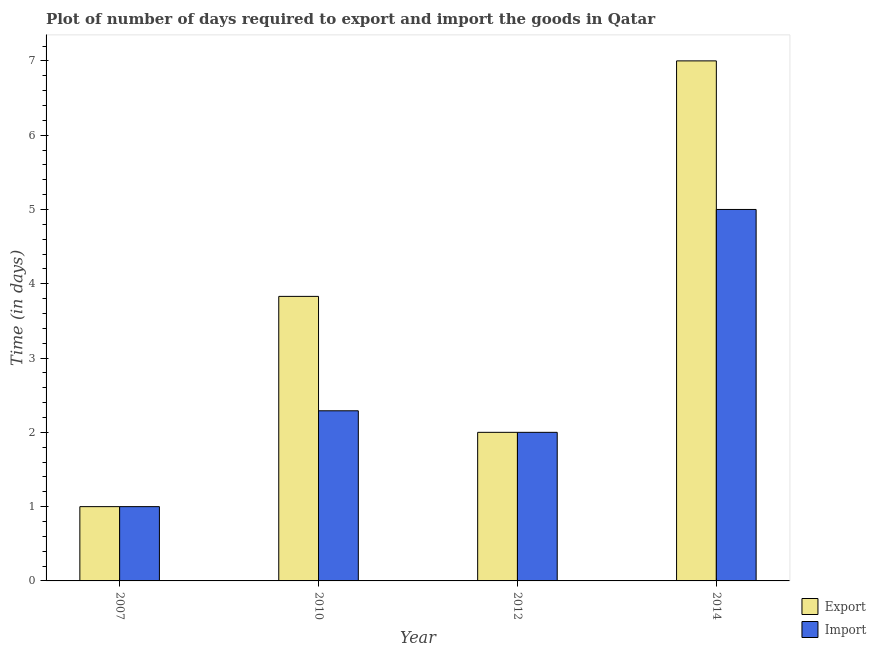How many different coloured bars are there?
Make the answer very short. 2. Are the number of bars on each tick of the X-axis equal?
Offer a very short reply. Yes. How many bars are there on the 3rd tick from the left?
Provide a succinct answer. 2. What is the time required to import in 2007?
Your answer should be compact. 1. Across all years, what is the maximum time required to import?
Your answer should be compact. 5. In which year was the time required to import maximum?
Your answer should be compact. 2014. In which year was the time required to import minimum?
Ensure brevity in your answer.  2007. What is the total time required to import in the graph?
Provide a short and direct response. 10.29. What is the difference between the time required to import in 2012 and that in 2014?
Offer a very short reply. -3. What is the difference between the time required to export in 2012 and the time required to import in 2010?
Offer a very short reply. -1.83. What is the average time required to import per year?
Provide a succinct answer. 2.57. In the year 2012, what is the difference between the time required to import and time required to export?
Your response must be concise. 0. What is the ratio of the time required to export in 2010 to that in 2014?
Your answer should be compact. 0.55. Is the time required to export in 2007 less than that in 2012?
Keep it short and to the point. Yes. What is the difference between the highest and the second highest time required to import?
Your answer should be very brief. 2.71. In how many years, is the time required to import greater than the average time required to import taken over all years?
Keep it short and to the point. 1. Is the sum of the time required to import in 2012 and 2014 greater than the maximum time required to export across all years?
Offer a very short reply. Yes. What does the 1st bar from the left in 2010 represents?
Keep it short and to the point. Export. What does the 1st bar from the right in 2010 represents?
Ensure brevity in your answer.  Import. How many bars are there?
Provide a short and direct response. 8. Are all the bars in the graph horizontal?
Your answer should be compact. No. What is the difference between two consecutive major ticks on the Y-axis?
Give a very brief answer. 1. Are the values on the major ticks of Y-axis written in scientific E-notation?
Make the answer very short. No. Does the graph contain any zero values?
Your answer should be very brief. No. How are the legend labels stacked?
Offer a very short reply. Vertical. What is the title of the graph?
Offer a very short reply. Plot of number of days required to export and import the goods in Qatar. What is the label or title of the Y-axis?
Make the answer very short. Time (in days). What is the Time (in days) in Export in 2007?
Offer a very short reply. 1. What is the Time (in days) of Export in 2010?
Your response must be concise. 3.83. What is the Time (in days) in Import in 2010?
Your answer should be compact. 2.29. What is the Time (in days) of Export in 2012?
Your answer should be compact. 2. What is the Time (in days) of Import in 2012?
Ensure brevity in your answer.  2. Across all years, what is the minimum Time (in days) of Import?
Make the answer very short. 1. What is the total Time (in days) of Export in the graph?
Your response must be concise. 13.83. What is the total Time (in days) in Import in the graph?
Give a very brief answer. 10.29. What is the difference between the Time (in days) of Export in 2007 and that in 2010?
Offer a terse response. -2.83. What is the difference between the Time (in days) in Import in 2007 and that in 2010?
Your answer should be very brief. -1.29. What is the difference between the Time (in days) in Export in 2007 and that in 2012?
Offer a very short reply. -1. What is the difference between the Time (in days) of Export in 2007 and that in 2014?
Provide a succinct answer. -6. What is the difference between the Time (in days) in Import in 2007 and that in 2014?
Offer a very short reply. -4. What is the difference between the Time (in days) of Export in 2010 and that in 2012?
Your response must be concise. 1.83. What is the difference between the Time (in days) in Import in 2010 and that in 2012?
Keep it short and to the point. 0.29. What is the difference between the Time (in days) in Export in 2010 and that in 2014?
Your response must be concise. -3.17. What is the difference between the Time (in days) of Import in 2010 and that in 2014?
Your answer should be compact. -2.71. What is the difference between the Time (in days) of Export in 2012 and that in 2014?
Your answer should be compact. -5. What is the difference between the Time (in days) of Export in 2007 and the Time (in days) of Import in 2010?
Keep it short and to the point. -1.29. What is the difference between the Time (in days) in Export in 2007 and the Time (in days) in Import in 2012?
Your response must be concise. -1. What is the difference between the Time (in days) in Export in 2007 and the Time (in days) in Import in 2014?
Provide a short and direct response. -4. What is the difference between the Time (in days) of Export in 2010 and the Time (in days) of Import in 2012?
Offer a terse response. 1.83. What is the difference between the Time (in days) of Export in 2010 and the Time (in days) of Import in 2014?
Keep it short and to the point. -1.17. What is the difference between the Time (in days) in Export in 2012 and the Time (in days) in Import in 2014?
Provide a short and direct response. -3. What is the average Time (in days) in Export per year?
Your answer should be compact. 3.46. What is the average Time (in days) in Import per year?
Your answer should be very brief. 2.57. In the year 2010, what is the difference between the Time (in days) in Export and Time (in days) in Import?
Provide a succinct answer. 1.54. In the year 2012, what is the difference between the Time (in days) of Export and Time (in days) of Import?
Your answer should be compact. 0. What is the ratio of the Time (in days) in Export in 2007 to that in 2010?
Offer a very short reply. 0.26. What is the ratio of the Time (in days) in Import in 2007 to that in 2010?
Your answer should be compact. 0.44. What is the ratio of the Time (in days) of Export in 2007 to that in 2012?
Provide a succinct answer. 0.5. What is the ratio of the Time (in days) in Export in 2007 to that in 2014?
Provide a succinct answer. 0.14. What is the ratio of the Time (in days) of Export in 2010 to that in 2012?
Keep it short and to the point. 1.92. What is the ratio of the Time (in days) in Import in 2010 to that in 2012?
Your response must be concise. 1.15. What is the ratio of the Time (in days) of Export in 2010 to that in 2014?
Ensure brevity in your answer.  0.55. What is the ratio of the Time (in days) in Import in 2010 to that in 2014?
Provide a succinct answer. 0.46. What is the ratio of the Time (in days) of Export in 2012 to that in 2014?
Keep it short and to the point. 0.29. What is the difference between the highest and the second highest Time (in days) in Export?
Provide a succinct answer. 3.17. What is the difference between the highest and the second highest Time (in days) of Import?
Keep it short and to the point. 2.71. What is the difference between the highest and the lowest Time (in days) of Export?
Ensure brevity in your answer.  6. What is the difference between the highest and the lowest Time (in days) of Import?
Offer a very short reply. 4. 